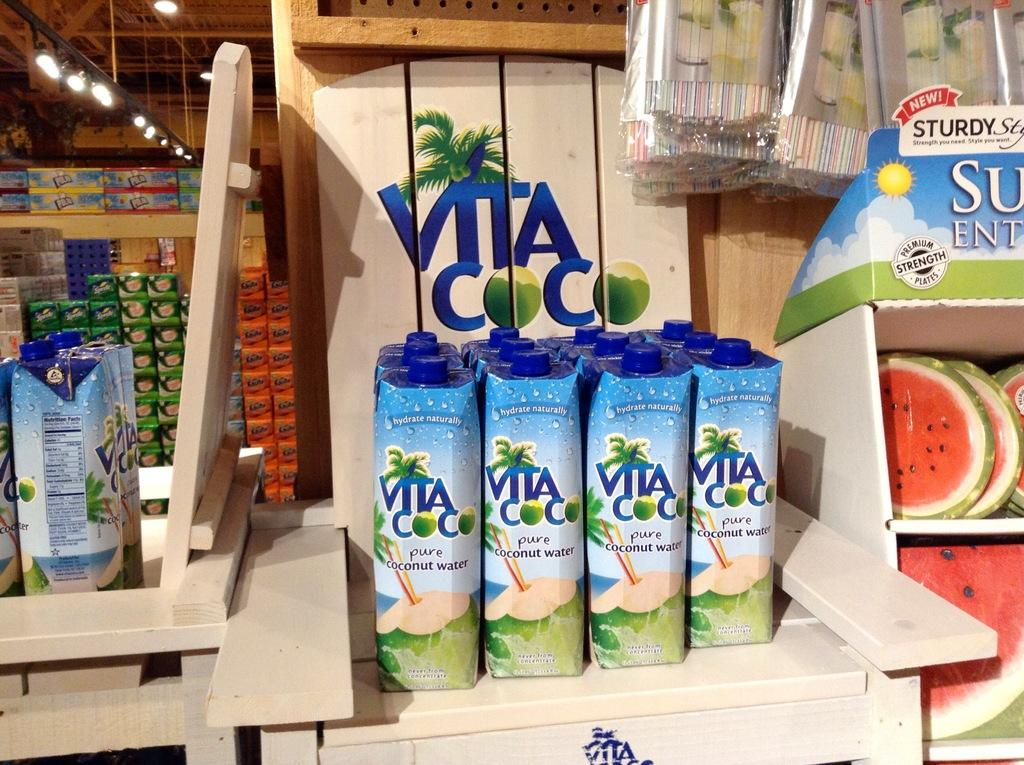<image>
Provide a brief description of the given image. Many bottles of Vita Coco on display in a store. 